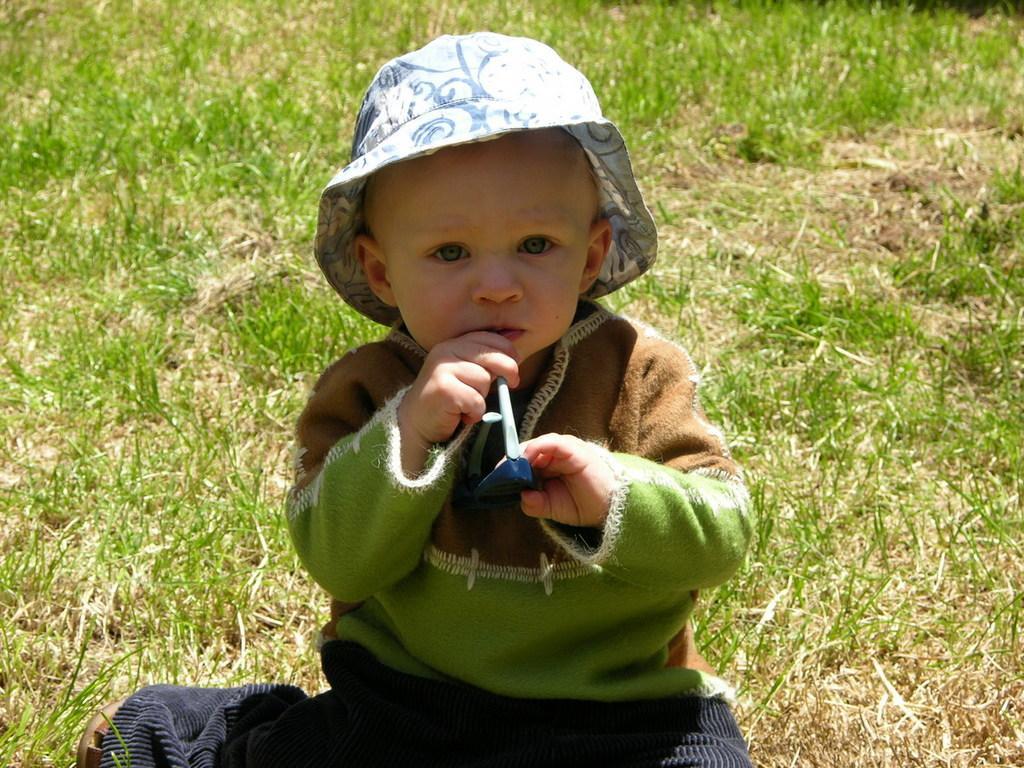Can you describe this image briefly? In this image in front there is a boy holding some object in his hands. At the bottom of the image there is grass on the surface. 